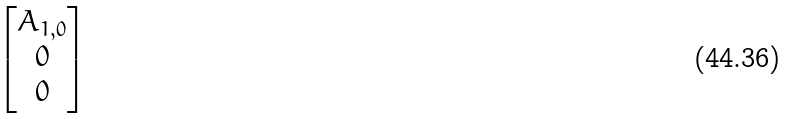Convert formula to latex. <formula><loc_0><loc_0><loc_500><loc_500>\begin{bmatrix} A _ { 1 , 0 } \\ 0 \\ 0 \end{bmatrix}</formula> 